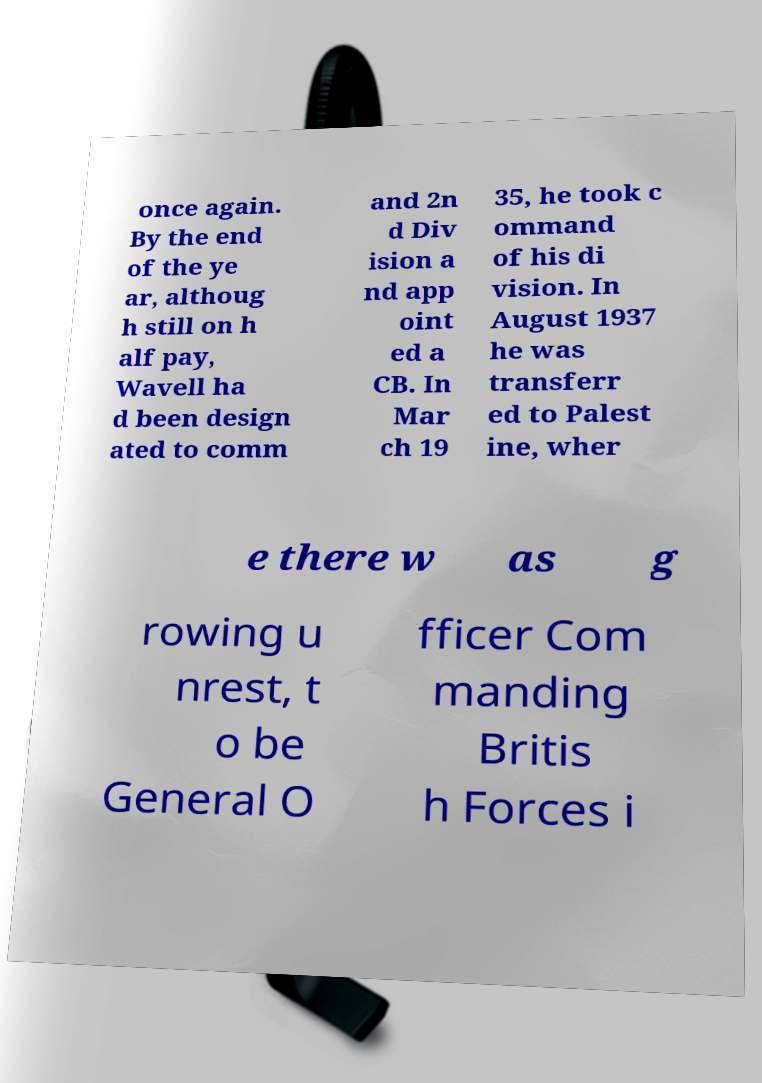There's text embedded in this image that I need extracted. Can you transcribe it verbatim? once again. By the end of the ye ar, althoug h still on h alf pay, Wavell ha d been design ated to comm and 2n d Div ision a nd app oint ed a CB. In Mar ch 19 35, he took c ommand of his di vision. In August 1937 he was transferr ed to Palest ine, wher e there w as g rowing u nrest, t o be General O fficer Com manding Britis h Forces i 